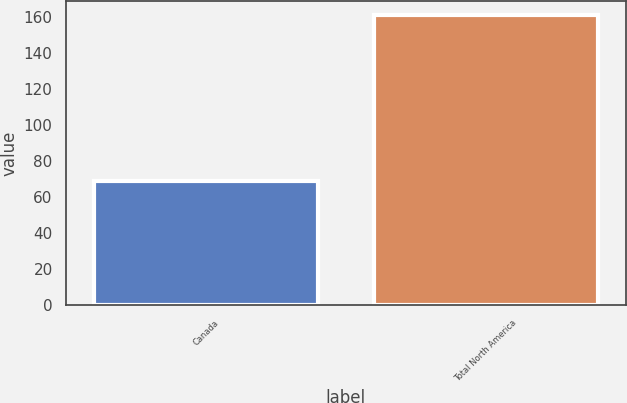Convert chart. <chart><loc_0><loc_0><loc_500><loc_500><bar_chart><fcel>Canada<fcel>Total North America<nl><fcel>69<fcel>161<nl></chart> 